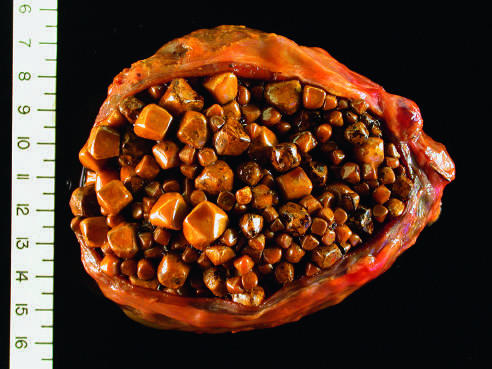what is thickened and fibrotic due to chronic cholecystitis?
Answer the question using a single word or phrase. The wall of the gallbladder 